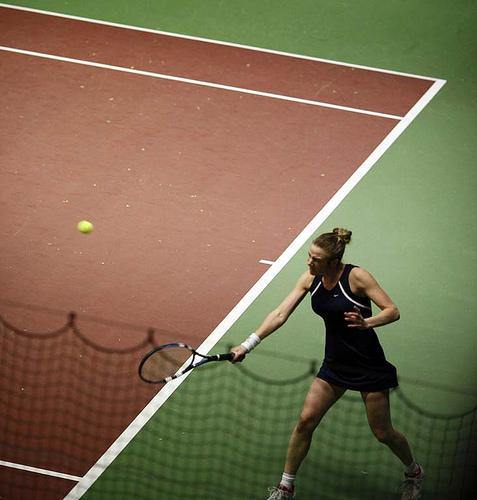Who is the man in black?
Concise answer only. Tennis player. Is she going to hit the ball?
Be succinct. Yes. What color is the woman's outfit?
Give a very brief answer. Black. What sport is being played?
Quick response, please. Tennis. 